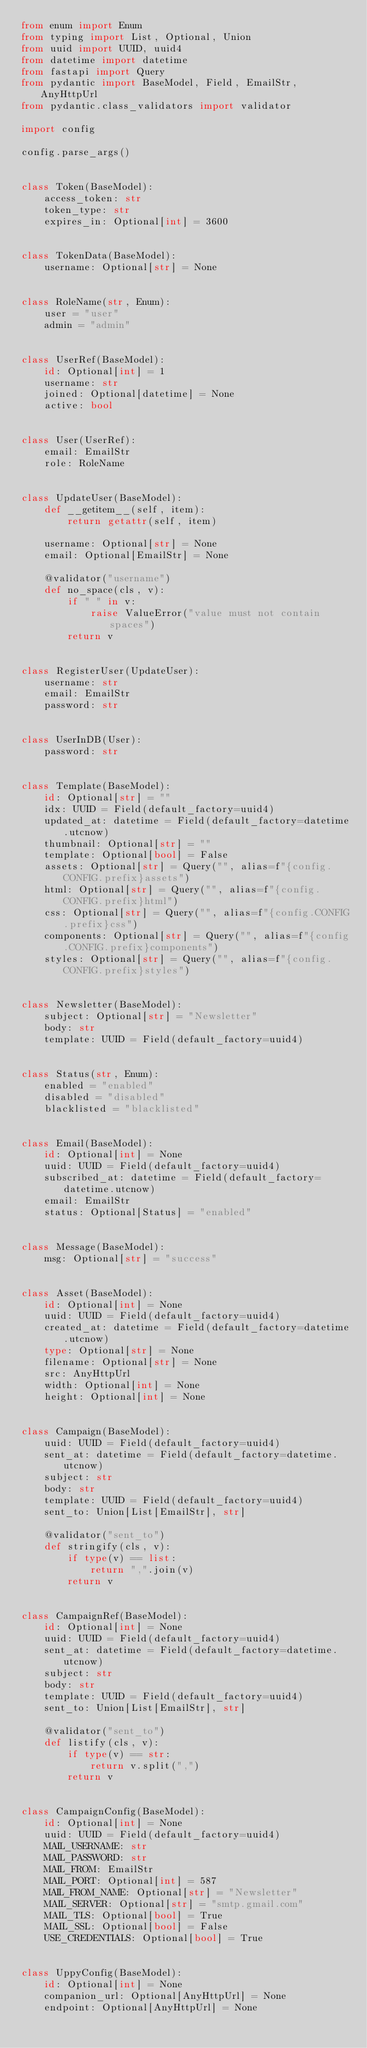<code> <loc_0><loc_0><loc_500><loc_500><_Python_>from enum import Enum
from typing import List, Optional, Union
from uuid import UUID, uuid4
from datetime import datetime
from fastapi import Query
from pydantic import BaseModel, Field, EmailStr, AnyHttpUrl
from pydantic.class_validators import validator

import config

config.parse_args()


class Token(BaseModel):
    access_token: str
    token_type: str
    expires_in: Optional[int] = 3600


class TokenData(BaseModel):
    username: Optional[str] = None


class RoleName(str, Enum):
    user = "user"
    admin = "admin"


class UserRef(BaseModel):
    id: Optional[int] = 1
    username: str
    joined: Optional[datetime] = None
    active: bool


class User(UserRef):
    email: EmailStr
    role: RoleName


class UpdateUser(BaseModel):
    def __getitem__(self, item):
        return getattr(self, item)

    username: Optional[str] = None
    email: Optional[EmailStr] = None

    @validator("username")
    def no_space(cls, v):
        if " " in v:
            raise ValueError("value must not contain spaces")
        return v


class RegisterUser(UpdateUser):
    username: str
    email: EmailStr
    password: str


class UserInDB(User):
    password: str


class Template(BaseModel):
    id: Optional[str] = ""
    idx: UUID = Field(default_factory=uuid4)
    updated_at: datetime = Field(default_factory=datetime.utcnow)
    thumbnail: Optional[str] = ""
    template: Optional[bool] = False
    assets: Optional[str] = Query("", alias=f"{config.CONFIG.prefix}assets")
    html: Optional[str] = Query("", alias=f"{config.CONFIG.prefix}html")
    css: Optional[str] = Query("", alias=f"{config.CONFIG.prefix}css")
    components: Optional[str] = Query("", alias=f"{config.CONFIG.prefix}components")
    styles: Optional[str] = Query("", alias=f"{config.CONFIG.prefix}styles")


class Newsletter(BaseModel):
    subject: Optional[str] = "Newsletter"
    body: str
    template: UUID = Field(default_factory=uuid4)


class Status(str, Enum):
    enabled = "enabled"
    disabled = "disabled"
    blacklisted = "blacklisted"


class Email(BaseModel):
    id: Optional[int] = None
    uuid: UUID = Field(default_factory=uuid4)
    subscribed_at: datetime = Field(default_factory=datetime.utcnow)
    email: EmailStr
    status: Optional[Status] = "enabled"


class Message(BaseModel):
    msg: Optional[str] = "success"


class Asset(BaseModel):
    id: Optional[int] = None
    uuid: UUID = Field(default_factory=uuid4)
    created_at: datetime = Field(default_factory=datetime.utcnow)
    type: Optional[str] = None
    filename: Optional[str] = None
    src: AnyHttpUrl
    width: Optional[int] = None
    height: Optional[int] = None


class Campaign(BaseModel):
    uuid: UUID = Field(default_factory=uuid4)
    sent_at: datetime = Field(default_factory=datetime.utcnow)
    subject: str
    body: str
    template: UUID = Field(default_factory=uuid4)
    sent_to: Union[List[EmailStr], str]

    @validator("sent_to")
    def stringify(cls, v):
        if type(v) == list:
            return ",".join(v)
        return v


class CampaignRef(BaseModel):
    id: Optional[int] = None
    uuid: UUID = Field(default_factory=uuid4)
    sent_at: datetime = Field(default_factory=datetime.utcnow)
    subject: str
    body: str
    template: UUID = Field(default_factory=uuid4)
    sent_to: Union[List[EmailStr], str]

    @validator("sent_to")
    def listify(cls, v):
        if type(v) == str:
            return v.split(",")
        return v


class CampaignConfig(BaseModel):
    id: Optional[int] = None
    uuid: UUID = Field(default_factory=uuid4)
    MAIL_USERNAME: str
    MAIL_PASSWORD: str
    MAIL_FROM: EmailStr
    MAIL_PORT: Optional[int] = 587
    MAIL_FROM_NAME: Optional[str] = "Newsletter"
    MAIL_SERVER: Optional[str] = "smtp.gmail.com"
    MAIL_TLS: Optional[bool] = True
    MAIL_SSL: Optional[bool] = False
    USE_CREDENTIALS: Optional[bool] = True


class UppyConfig(BaseModel):
    id: Optional[int] = None
    companion_url: Optional[AnyHttpUrl] = None
    endpoint: Optional[AnyHttpUrl] = None
</code> 